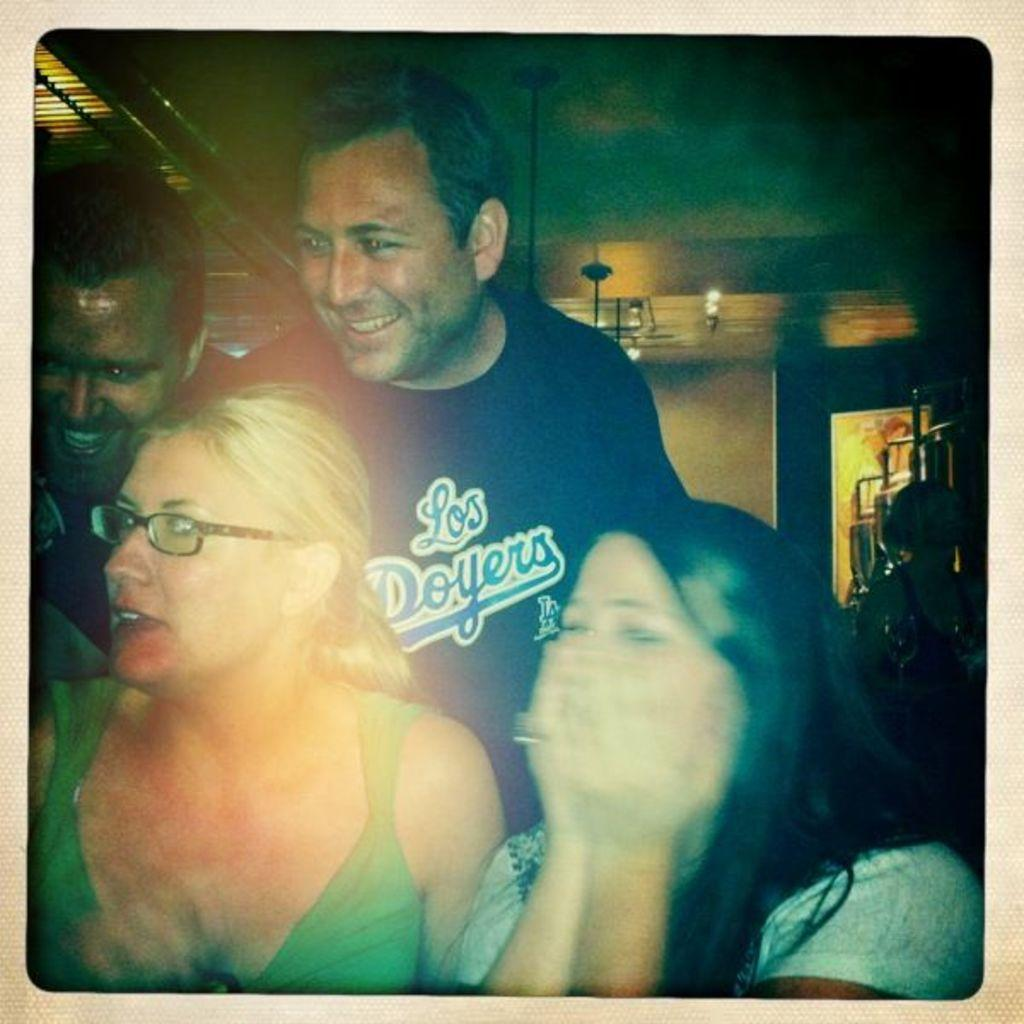How many people are in the image? There are people in the image, but the exact number is not specified. Can you describe any specific features of one of the people? One person is wearing glasses. What can be seen in the background of the image? In the background of the image, there are lights, rods, other objects, and a wall. What might the rods be used for? The purpose of the rods is not specified, but they could be used for various purposes such as support or decoration. What force is causing the person in the middle to fall over? There is no person in the middle falling over in the image, and therefore no force is causing such an event. 